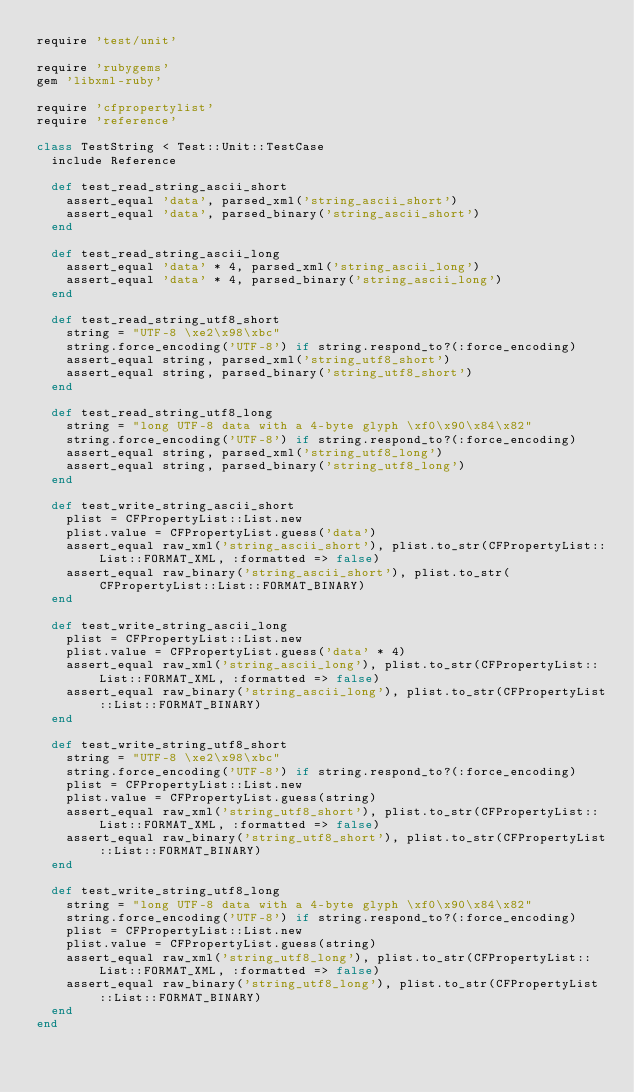<code> <loc_0><loc_0><loc_500><loc_500><_Ruby_>require 'test/unit'

require 'rubygems'
gem 'libxml-ruby'

require 'cfpropertylist'
require 'reference'

class TestString < Test::Unit::TestCase
  include Reference
  
  def test_read_string_ascii_short
    assert_equal 'data', parsed_xml('string_ascii_short')
    assert_equal 'data', parsed_binary('string_ascii_short')
  end
  
  def test_read_string_ascii_long
    assert_equal 'data' * 4, parsed_xml('string_ascii_long')
    assert_equal 'data' * 4, parsed_binary('string_ascii_long')
  end
  
  def test_read_string_utf8_short
    string = "UTF-8 \xe2\x98\xbc"
    string.force_encoding('UTF-8') if string.respond_to?(:force_encoding)
    assert_equal string, parsed_xml('string_utf8_short')
    assert_equal string, parsed_binary('string_utf8_short')
  end
  
  def test_read_string_utf8_long
    string = "long UTF-8 data with a 4-byte glyph \xf0\x90\x84\x82"
    string.force_encoding('UTF-8') if string.respond_to?(:force_encoding)
    assert_equal string, parsed_xml('string_utf8_long')
    assert_equal string, parsed_binary('string_utf8_long')
  end
  
  def test_write_string_ascii_short
    plist = CFPropertyList::List.new
    plist.value = CFPropertyList.guess('data')
    assert_equal raw_xml('string_ascii_short'), plist.to_str(CFPropertyList::List::FORMAT_XML, :formatted => false)
    assert_equal raw_binary('string_ascii_short'), plist.to_str(CFPropertyList::List::FORMAT_BINARY)
  end
  
  def test_write_string_ascii_long
    plist = CFPropertyList::List.new
    plist.value = CFPropertyList.guess('data' * 4)
    assert_equal raw_xml('string_ascii_long'), plist.to_str(CFPropertyList::List::FORMAT_XML, :formatted => false)
    assert_equal raw_binary('string_ascii_long'), plist.to_str(CFPropertyList::List::FORMAT_BINARY)
  end
  
  def test_write_string_utf8_short
    string = "UTF-8 \xe2\x98\xbc"
    string.force_encoding('UTF-8') if string.respond_to?(:force_encoding)
    plist = CFPropertyList::List.new
    plist.value = CFPropertyList.guess(string)
    assert_equal raw_xml('string_utf8_short'), plist.to_str(CFPropertyList::List::FORMAT_XML, :formatted => false)
    assert_equal raw_binary('string_utf8_short'), plist.to_str(CFPropertyList::List::FORMAT_BINARY)
  end
  
  def test_write_string_utf8_long
    string = "long UTF-8 data with a 4-byte glyph \xf0\x90\x84\x82"
    string.force_encoding('UTF-8') if string.respond_to?(:force_encoding)
    plist = CFPropertyList::List.new
    plist.value = CFPropertyList.guess(string)
    assert_equal raw_xml('string_utf8_long'), plist.to_str(CFPropertyList::List::FORMAT_XML, :formatted => false)
    assert_equal raw_binary('string_utf8_long'), plist.to_str(CFPropertyList::List::FORMAT_BINARY)
  end
end
</code> 